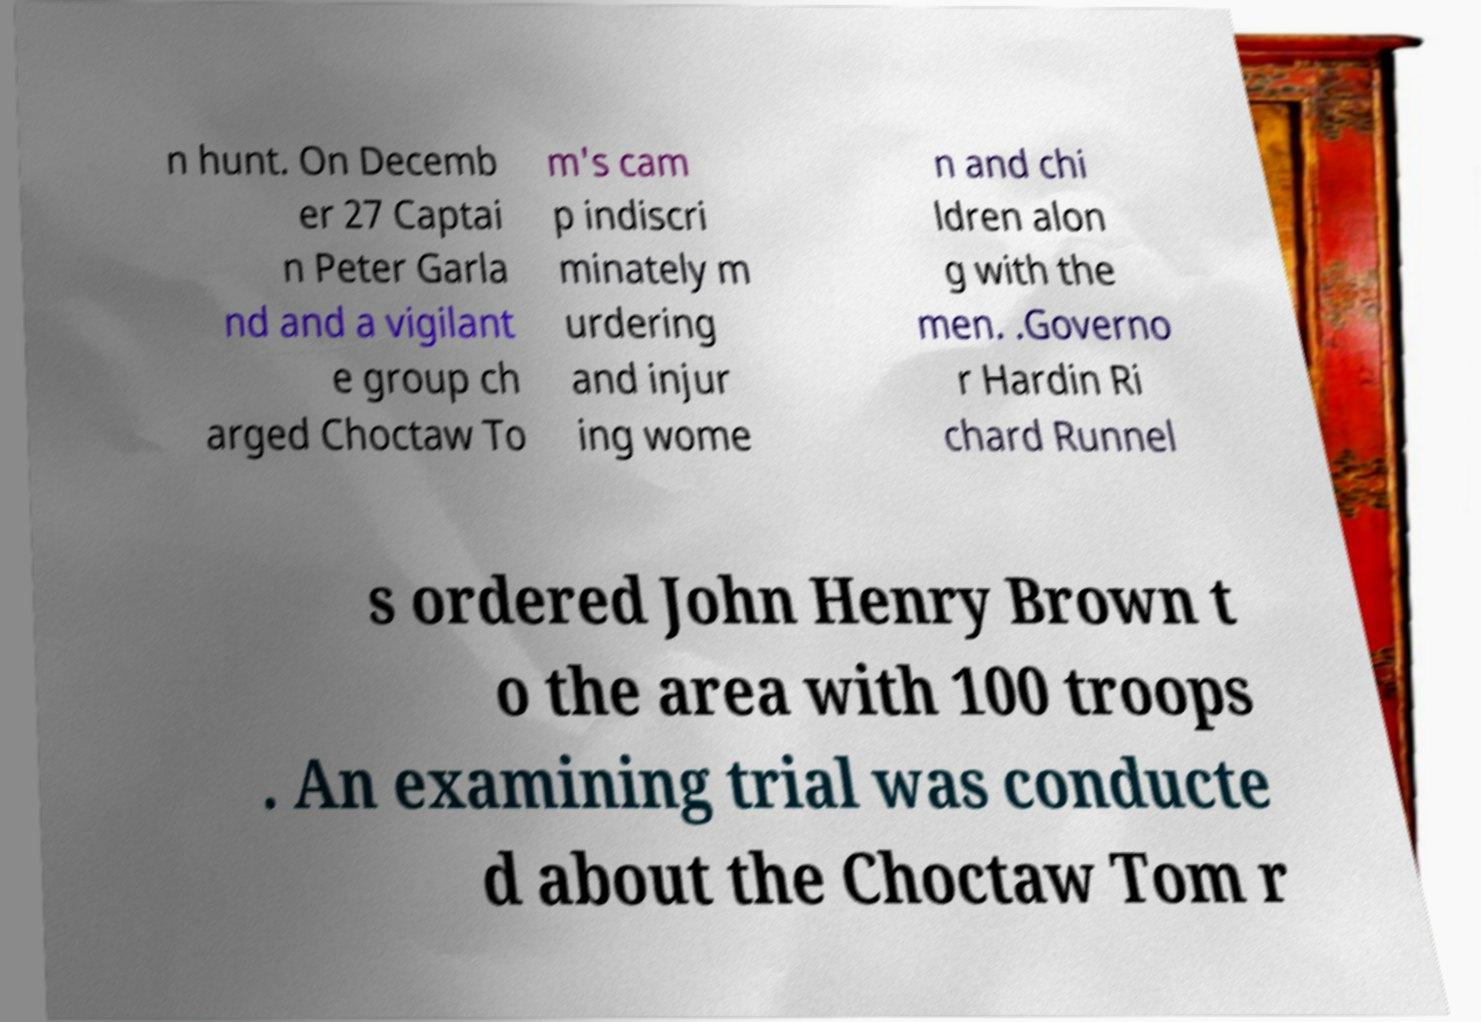Can you accurately transcribe the text from the provided image for me? n hunt. On Decemb er 27 Captai n Peter Garla nd and a vigilant e group ch arged Choctaw To m's cam p indiscri minately m urdering and injur ing wome n and chi ldren alon g with the men. .Governo r Hardin Ri chard Runnel s ordered John Henry Brown t o the area with 100 troops . An examining trial was conducte d about the Choctaw Tom r 